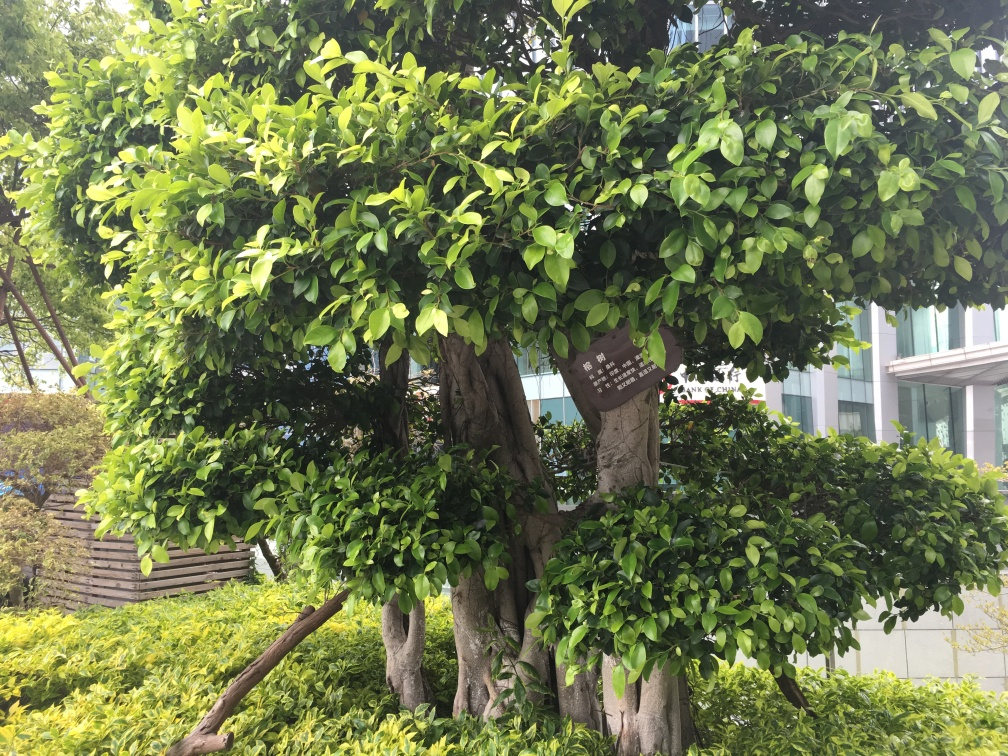What makes the contours and texture in this image quality clear and obvious? The contours and texture in this image are clear and obvious due to the high definition and clarity of the photograph. Each leaf and branch are well-defined, and their textures are distinct, indicating that it was taken with a high-quality camera or under suitable lighting conditions, which enhances the details. 